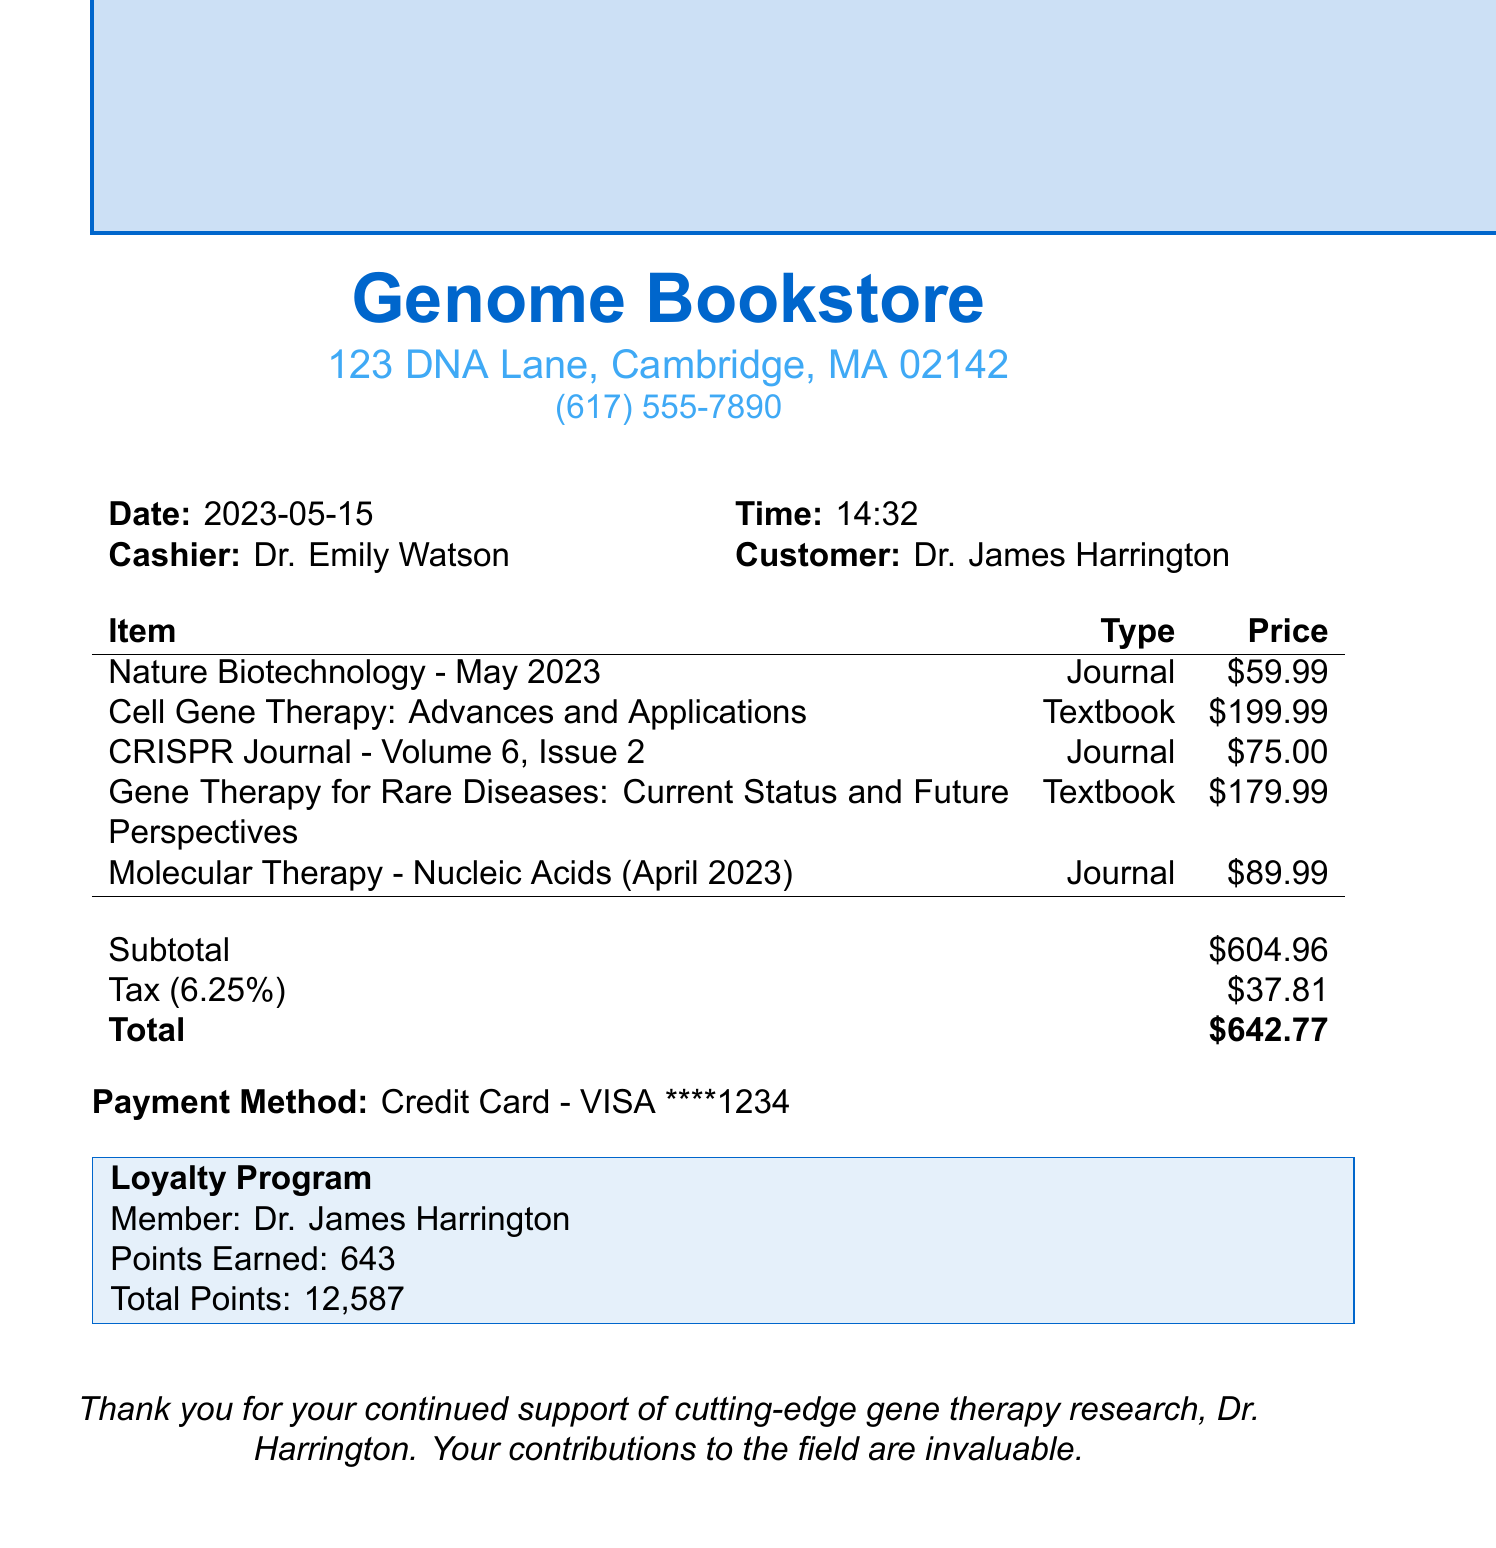what is the name of the bookstore? The bookstore's name is prominently displayed at the top of the receipt.
Answer: Genome Bookstore who was the cashier for this transaction? The cashier's name is mentioned in the receipt under the cashier section.
Answer: Dr. Emily Watson what is the total amount paid? The total is listed at the bottom of the receipt, summarizing all costs including tax.
Answer: $642.77 how many journal items were purchased? The receipt lists multiple items, specifying which are journals; counting them provides the answer.
Answer: 3 what is the price of the textbook by Jennifer Doudna? The price of the textbook is detailed alongside its title in the items list.
Answer: $199.99 how many loyalty points has Dr. Harrington earned from this purchase? The points earned are specified in the loyalty program section after the purchase summary.
Answer: 643 what is the tax rate applied to this transaction? The tax rate is explicitly stated on the receipt along with its calculation.
Answer: 6.25% what is the publishing company for the "CRISPR Journal"? The publishing company is indicated next to the journal title in the receipt items.
Answer: Mary Ann Liebert, Inc what is the date of this transaction? The date of the purchase is clearly stated at the top of the receipt.
Answer: 2023-05-15 